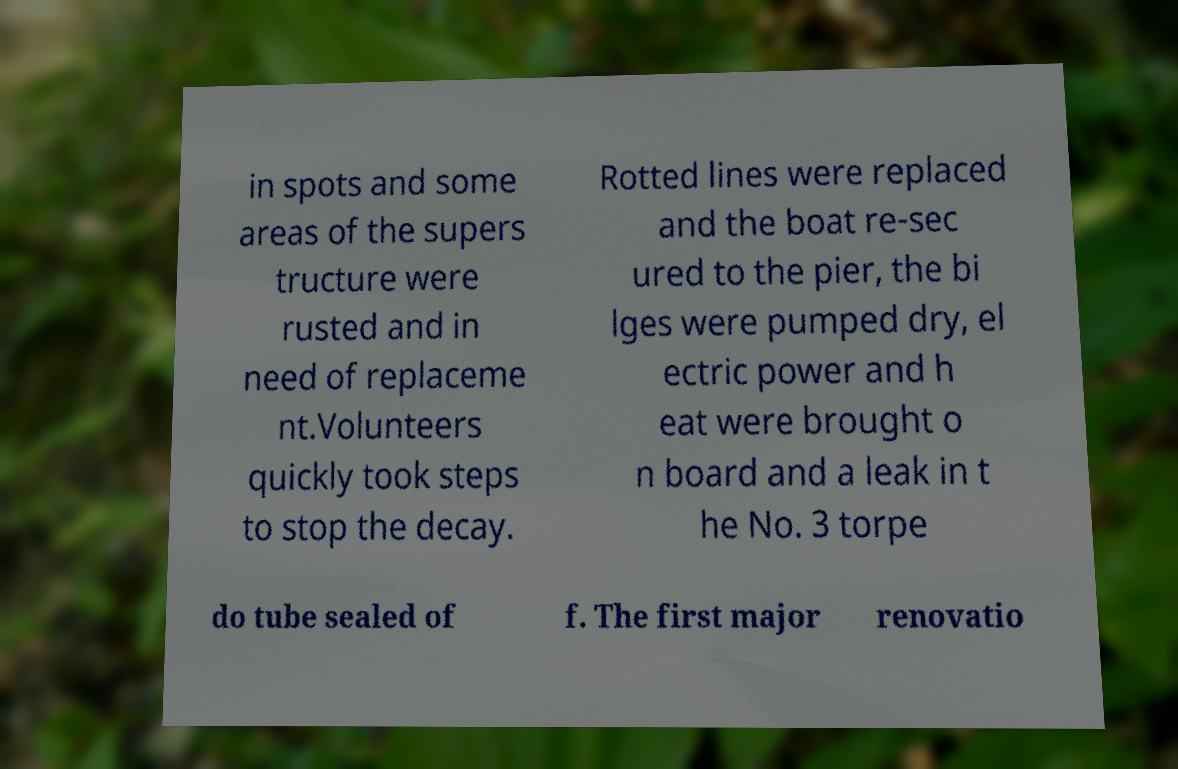Please identify and transcribe the text found in this image. in spots and some areas of the supers tructure were rusted and in need of replaceme nt.Volunteers quickly took steps to stop the decay. Rotted lines were replaced and the boat re-sec ured to the pier, the bi lges were pumped dry, el ectric power and h eat were brought o n board and a leak in t he No. 3 torpe do tube sealed of f. The first major renovatio 